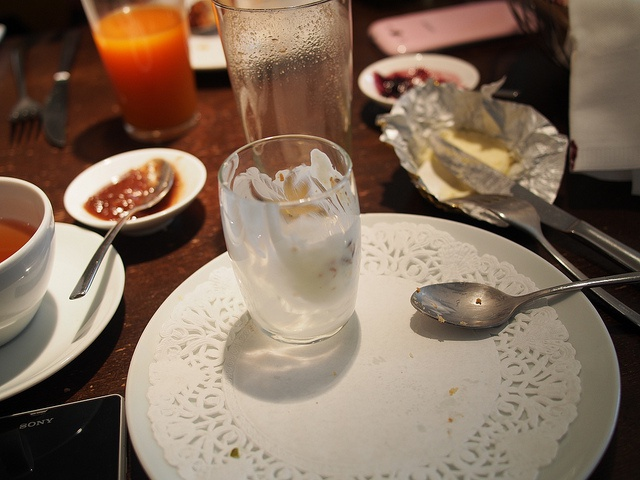Describe the objects in this image and their specific colors. I can see dining table in black, darkgray, maroon, and tan tones, cup in black, darkgray, and tan tones, cup in black, brown, gray, tan, and maroon tones, cup in black, maroon, red, and orange tones, and cell phone in black and gray tones in this image. 